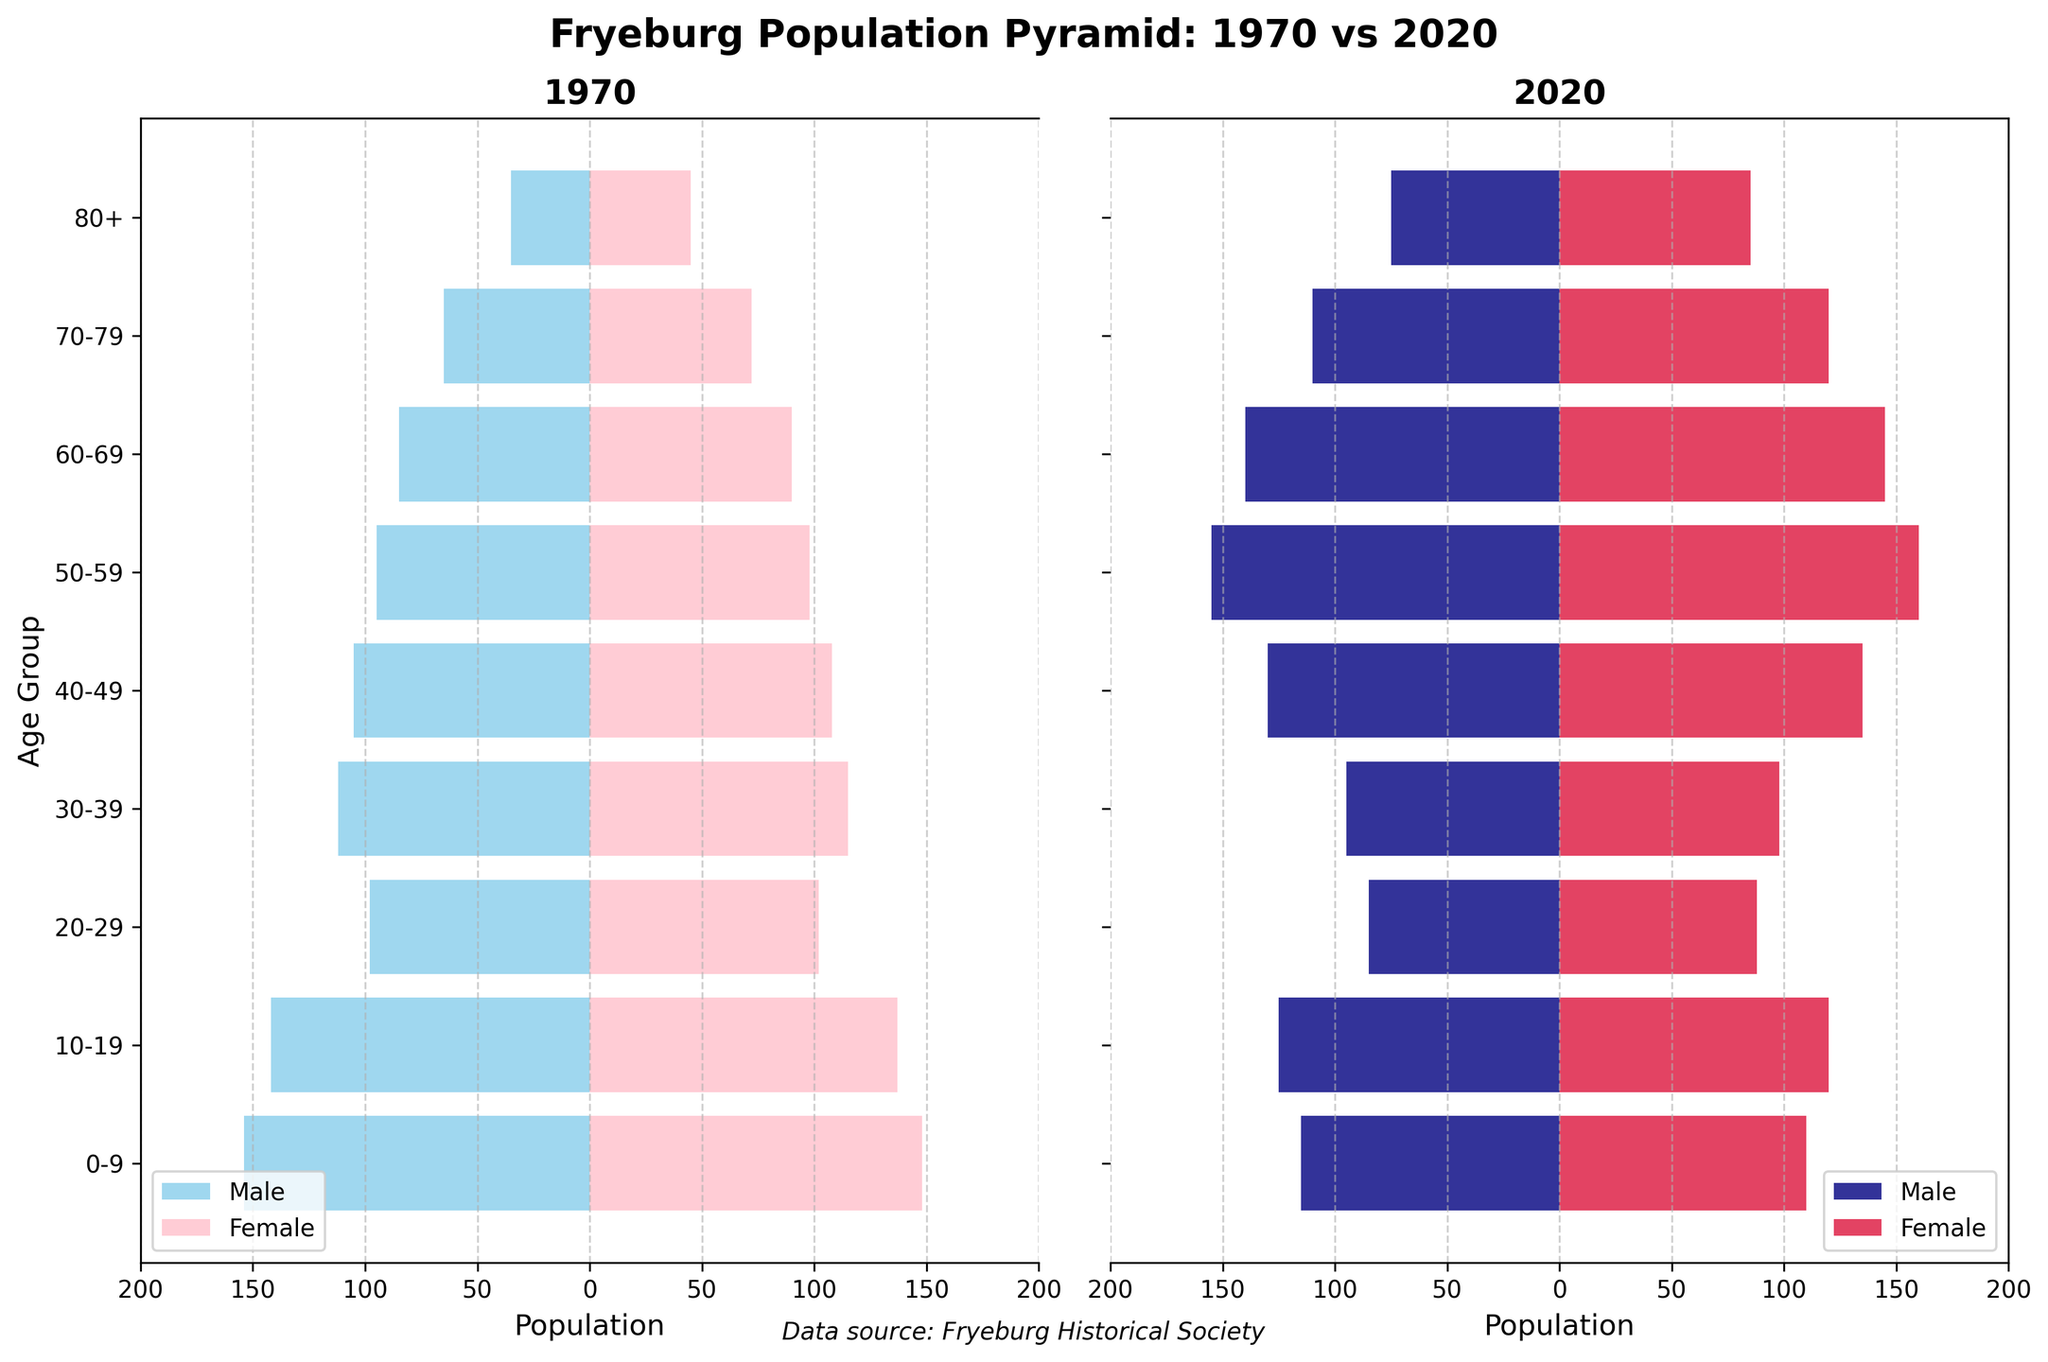What is the title of the figure? The title is located at the top of the figure and provides an overall context for the data shown. It reads "Fryeburg Population Pyramid: 1970 vs 2020"
Answer: Fryeburg Population Pyramid: 1970 vs 2020 Which age group had the highest male population in 2020? By looking at the length of the blue bars on the right-side chart for the year 2020, we compare the negative values since they represent the male population. The longest bar corresponds to the 50-59 age group.
Answer: 50-59 How do the female populations of the 30-39 age group compare between 1970 and 2020? Examine the lengths of the pink bars in the 30-39 age group for both charts. The 2020 bar is taller (98) compared to the 1970 bar (115). Subtract the 2020 value from the 1970 value for the difference.
Answer: 98 in 2020; 115 in 1970. The difference is 17 Which age group experienced the largest decline in the male population from 1970 to 2020? Subtract the male population in 2020 from that in 1970 for each age group to find which group has the largest decrease. The age group 0-9 shows a decline from 154 to 115, which is a decrease of 39, the highest among the groups.
Answer: 0-9 with a decline of 39 What is the total population for the 80+ age group in 2020? Add the male and female populations together for the 80+ group in 2020. Male (75) + Female (85) = 160
Answer: 160 How has the population distribution for the 50-59 age group changed from 1970 to 2020? Compare both the male and female populations of the 50-59 age group in 1970 and 2020. For 1970, males are 95, and females are 98. For 2020, males are 155, and females are 160. Subtract the 1970 values from the 2020 values to identify the changes. Males: 155 - 95 = 60 increase; Females: 160 - 98 = 62 increase.
Answer: Males increased by 60; Females increased by 62 Which age group had more females than males in both 1970 and 2020? For each age group, compare the lengths of the pink (females) and blue (males) bars for both years. The age group 80+ had more females than males in both 1970 (Females: 45, Males: 35) and 2020 (Females: 85, Males: 75).
Answer: 80+ Which age group saw an increase in both male and female populations from 1970 to 2020? To determine this, compare the lengths of the corresponding age group's bars for 1970 and 2020. The 50-59 age group saw increases in both genders (Male: 95 to 155, Female: 98 to 160).
Answer: 50-59 What percentage of the male population in 2020's 60-69 age group is of the total male population in the same age group in 1970? Calculate the percentage by dividing the male population in 2020 (140) by that of 1970 (85) and then multiplying by 100. (140 / 85) * 100 = 164.7%
Answer: 164.7% 